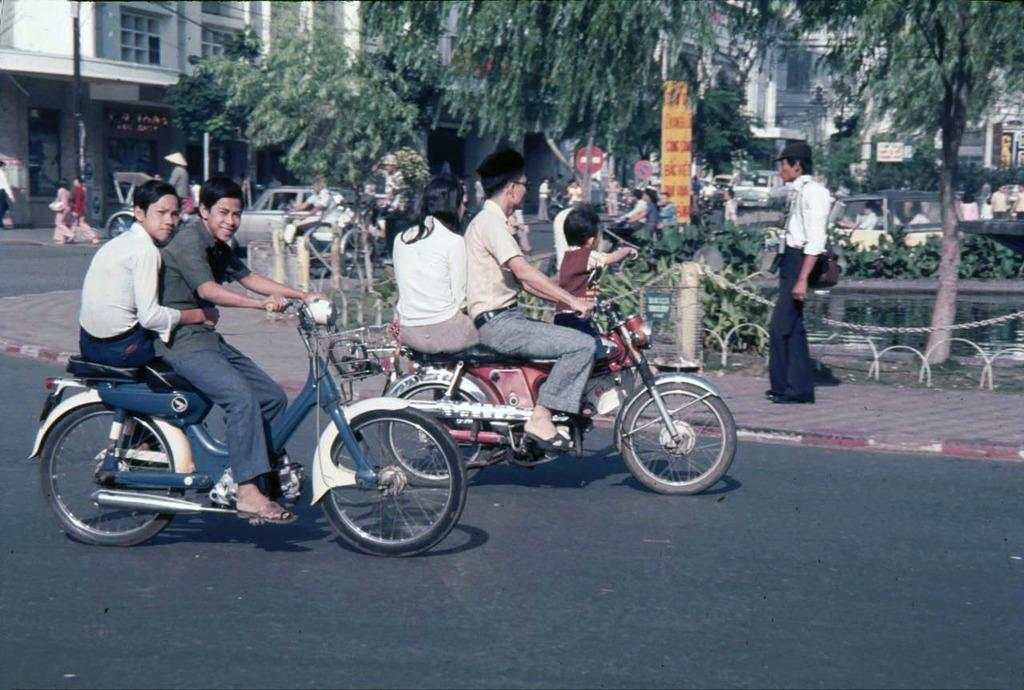What type of motor vehicle are the people on in the image? The information provided does not specify the type of motor vehicle. What is the person on the footpath doing in the image? The information provided does not specify the actions of the person on the footpath. What type of vegetation can be seen in the image? There are trees visible in the image. What type of structures can be seen in the image? There are buildings visible in the image. How many teeth can be seen in the mouth of the person on the footpath in the image? There is no person's mouth visible in the image, so it is not possible to determine the number of teeth. 